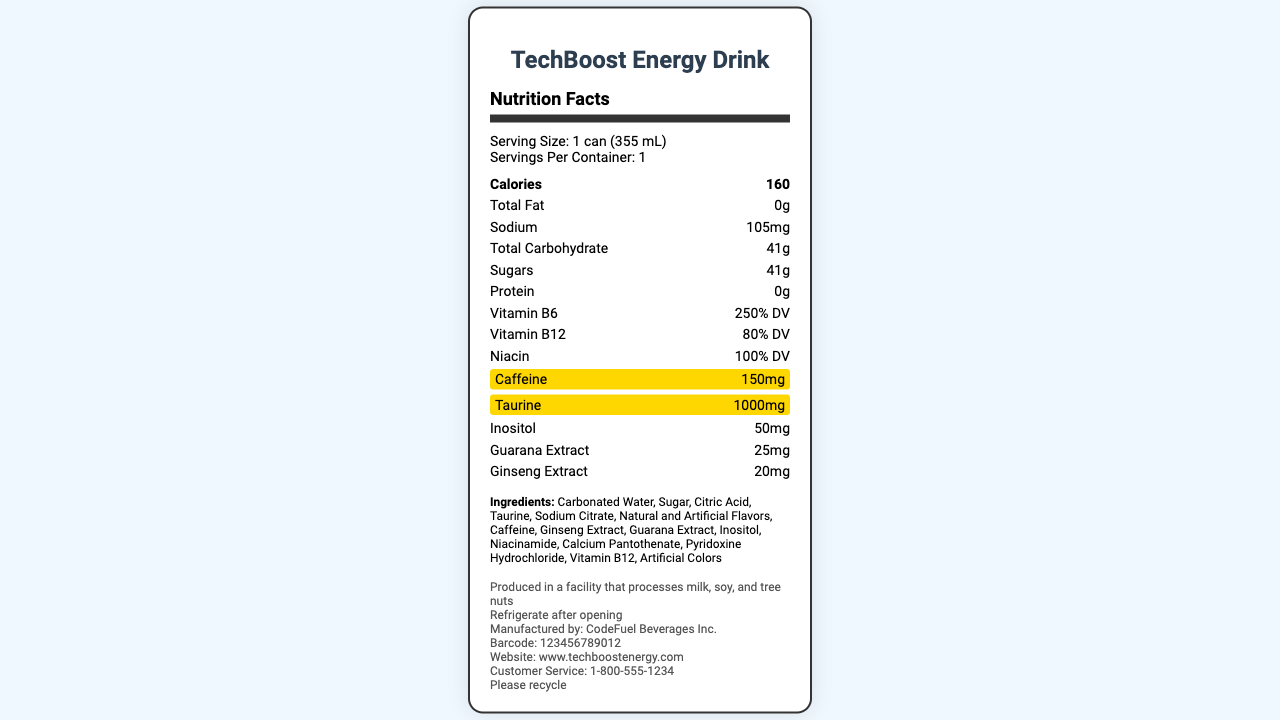What is the serving size for TechBoost Energy Drink? The document lists the serving size clearly under "Serving Size" as "1 can (355 mL)".
Answer: 1 can (355 mL) How many grams of sugars are there per serving? The document lists the amount of sugars under "Sugars" as "41g".
Answer: 41g What percentage of the daily value of Vitamin B6 does this energy drink provide? The document mentions "Vitamin B6 (250% DV)" in the list of nutrients.
Answer: 250% DV What is the caffeine content per serving of TechBoost Energy Drink? The caffeine content is highlighted in the document, listing "Caffeine (150mg)".
Answer: 150mg Which company manufactures TechBoost Energy Drink? The additional information section of the document states that the product is manufactured by "CodeFuel Beverages Inc."
Answer: CodeFuel Beverages Inc. What is the total carbohydrate content per serving? A. 35g B. 41g C. 50g D. 45g The document lists the total carbohydrate content as "41g".
Answer: B Which of the following ingredients is NOT listed in the document? I. Ginseng Extract II. Green Tea Extract III. Guarana Extract A. I B. II C. III D. I and III Green Tea Extract is not listed in the ingredient list provided in the document.
Answer: B Is TechBoost Energy Drink suitable for people with nut allergies? The allergen information states "Produced in a facility that processes milk, soy, and tree nuts," which suggests there is a risk of cross-contamination.
Answer: No Summarize the contents of the Nutrition Facts Label for TechBoost Energy Drink. The document outlines all nutritional and ingredient information necessary for understanding the beverage's contents, providing important dietary information and warnings.
Answer: The TechBoost Energy Drink Nutrition Facts Label provides details on serving size, calorie content, and a breakdown of various nutrients, including their amounts and daily values. Key highlighted nutrients include caffeine (150mg) and taurine (1000mg). Additional information includes allergen warnings, storage instructions, manufacturing details, and ingredient list. What is the phone number for customer service? The document lists "Customer Service: 1-800-555-1234" under additional information.
Answer: 1-800-555-1234 How many servings are in each container of TechBoost Energy Drink? The document clearly states "Servings Per Container: 1" in the serving information section.
Answer: 1 Does the document specify the amount of calcium in TechBoost Energy Drink? The document does not mention calcium content or make any reference to it.
Answer: Cannot be determined 